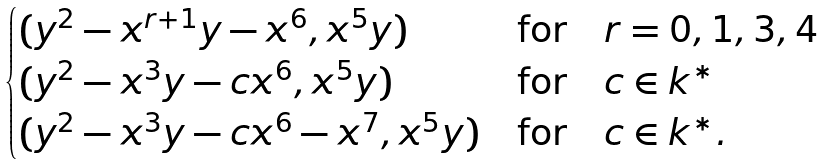<formula> <loc_0><loc_0><loc_500><loc_500>\begin{cases} ( y ^ { 2 } - x ^ { r + 1 } y - x ^ { 6 } , x ^ { 5 } y ) & \text {for} \quad r = 0 , 1 , 3 , 4 \\ ( y ^ { 2 } - x ^ { 3 } y - c x ^ { 6 } , x ^ { 5 } y ) & \text {for} \quad c \in k ^ { * } \\ ( y ^ { 2 } - x ^ { 3 } y - c x ^ { 6 } - x ^ { 7 } , x ^ { 5 } y ) & \text {for} \quad c \in k ^ { * } . \end{cases}</formula> 